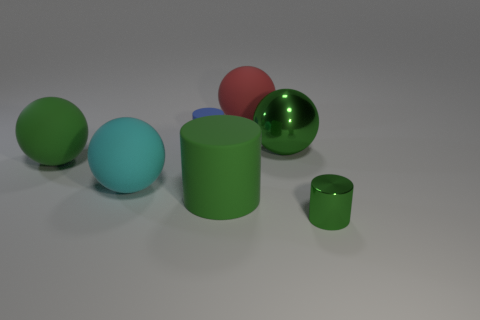Subtract all big matte spheres. How many spheres are left? 1 Add 2 blue rubber cylinders. How many objects exist? 9 Subtract all balls. How many objects are left? 3 Subtract 2 cylinders. How many cylinders are left? 1 Subtract all blue spheres. How many green cylinders are left? 2 Add 6 big cyan matte balls. How many big cyan matte balls exist? 7 Subtract all green cylinders. How many cylinders are left? 1 Subtract 0 gray cylinders. How many objects are left? 7 Subtract all purple spheres. Subtract all cyan cubes. How many spheres are left? 4 Subtract all large green metallic things. Subtract all small cyan rubber blocks. How many objects are left? 6 